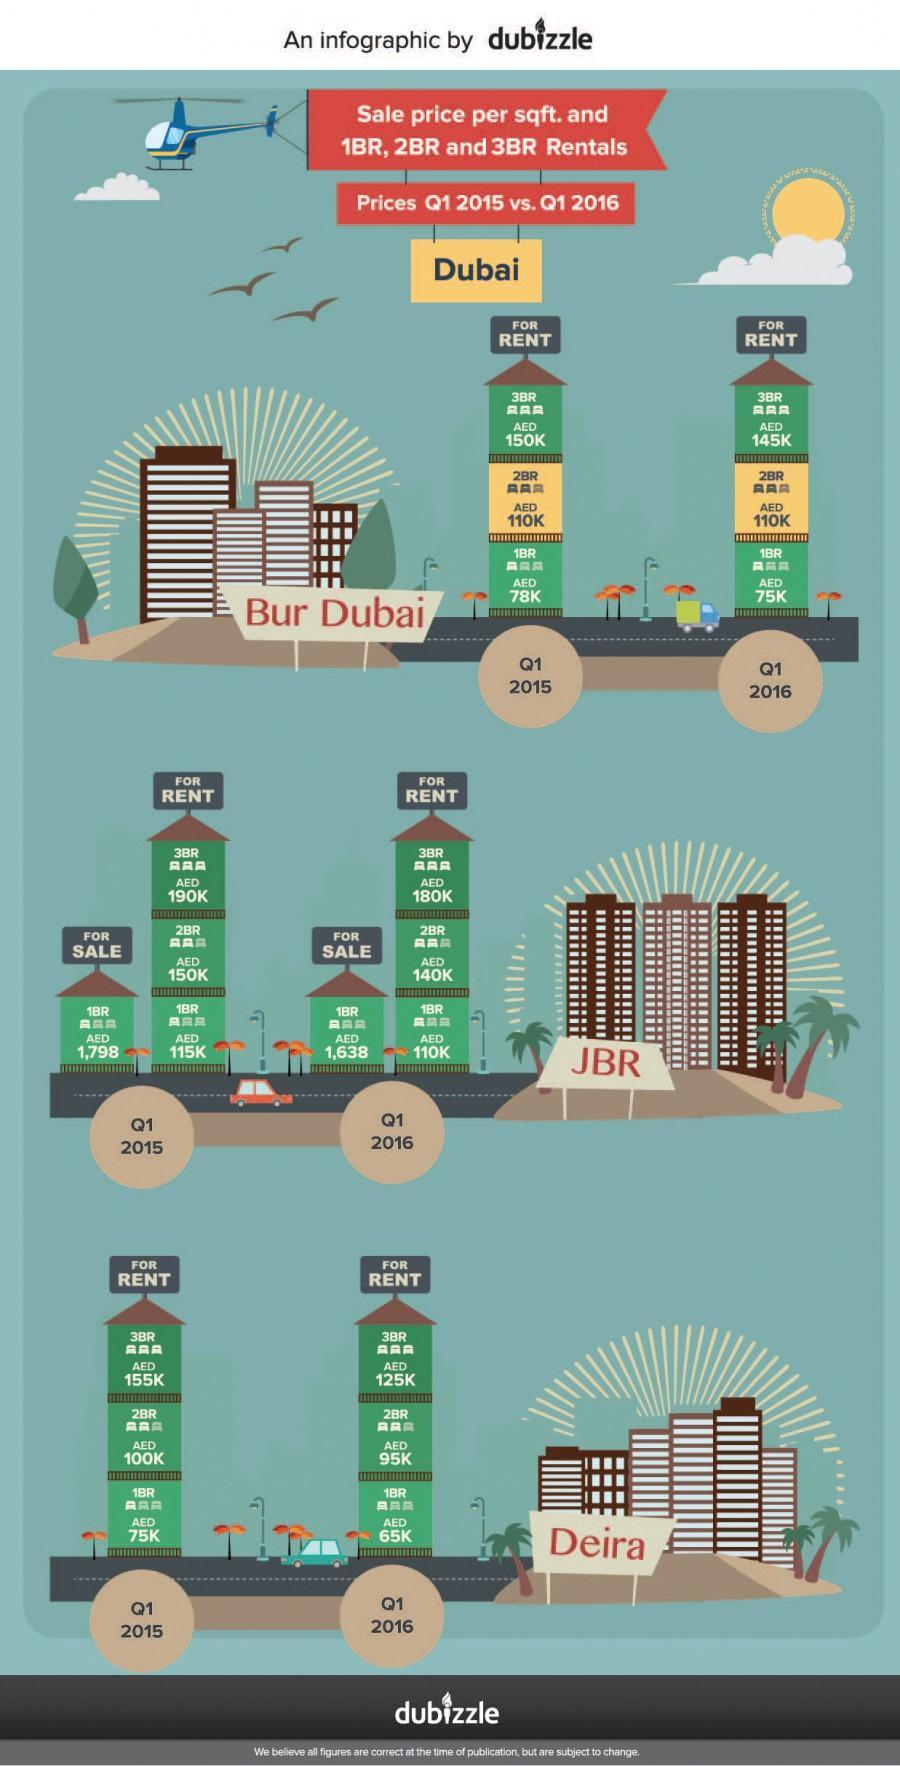Which year's first quarter showed the highest rent price for a single bedroom apartment in Bur Dubai?
Answer the question with a short phrase. 2015 Which year's first quarter showed the highest rent price for a double bedroom apartment in Deira, Dubai? 2015 What is the sales price per sqft. for a one-bedroom apartment in JBR, Dubai in Q1 2015? AED 1,798 What is the rent price for a three-bedroom apartment in Bur Dubai in Q1 2016? AED 145K What is the rent price for a one-bedroom apartment in Bur Dubai in Q1 2015? AED 78K What is the sales price per sqft. for a one-bedroom apartment in JBR, Dubai in Q1 2016? AED 1,638 What is the rent price for a two-bedroom apartment in Deira, Dubai in Q1 2015? AED 100K Which year's first quarter showed the lowest sales price for a single bedroom apartment in JBR, Dubai? 2016 